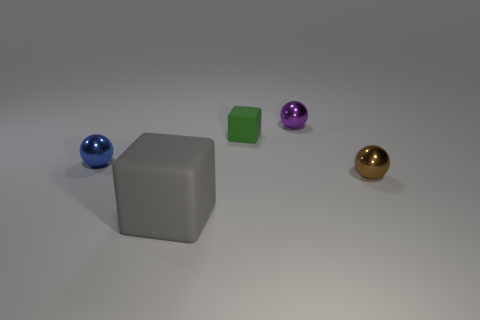Add 3 cylinders. How many objects exist? 8 Subtract all balls. How many objects are left? 2 Subtract 0 gray spheres. How many objects are left? 5 Subtract all brown metal spheres. Subtract all purple metallic things. How many objects are left? 3 Add 4 small green rubber things. How many small green rubber things are left? 5 Add 2 purple blocks. How many purple blocks exist? 2 